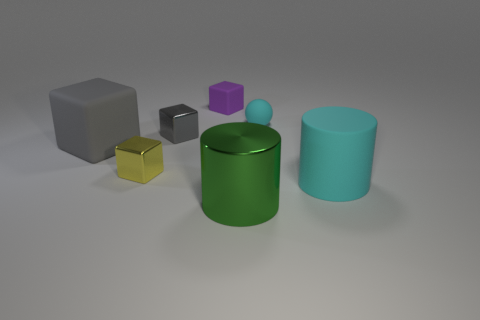Subtract all gray metallic blocks. How many blocks are left? 3 Subtract all purple cubes. How many cubes are left? 3 Subtract all cylinders. How many objects are left? 5 Subtract all brown spheres. How many gray cubes are left? 2 Subtract all small cyan matte balls. Subtract all tiny gray objects. How many objects are left? 5 Add 6 gray rubber blocks. How many gray rubber blocks are left? 7 Add 3 big cyan matte spheres. How many big cyan matte spheres exist? 3 Add 2 small matte objects. How many objects exist? 9 Subtract 0 brown blocks. How many objects are left? 7 Subtract 1 balls. How many balls are left? 0 